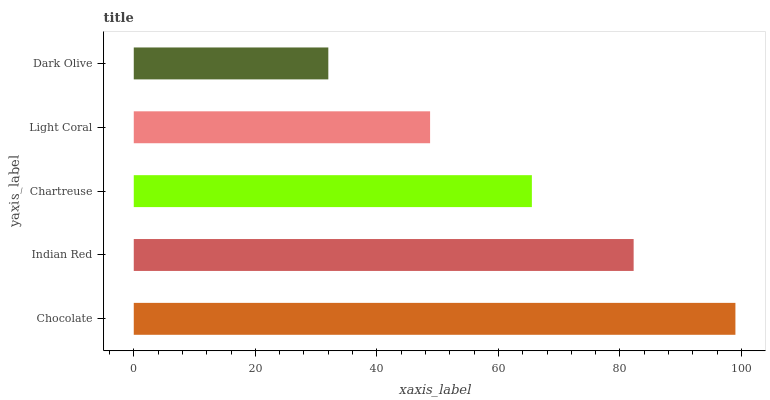Is Dark Olive the minimum?
Answer yes or no. Yes. Is Chocolate the maximum?
Answer yes or no. Yes. Is Indian Red the minimum?
Answer yes or no. No. Is Indian Red the maximum?
Answer yes or no. No. Is Chocolate greater than Indian Red?
Answer yes or no. Yes. Is Indian Red less than Chocolate?
Answer yes or no. Yes. Is Indian Red greater than Chocolate?
Answer yes or no. No. Is Chocolate less than Indian Red?
Answer yes or no. No. Is Chartreuse the high median?
Answer yes or no. Yes. Is Chartreuse the low median?
Answer yes or no. Yes. Is Indian Red the high median?
Answer yes or no. No. Is Dark Olive the low median?
Answer yes or no. No. 